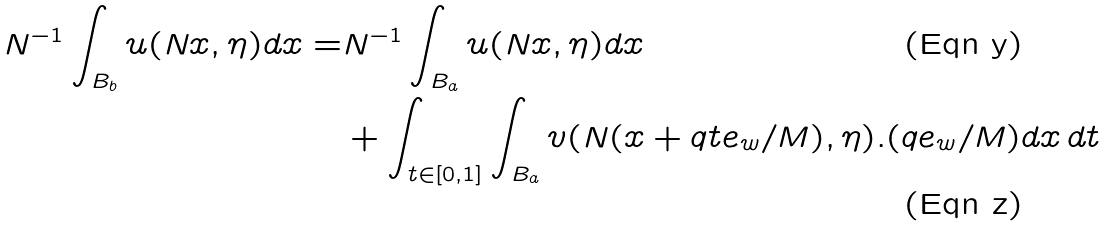<formula> <loc_0><loc_0><loc_500><loc_500>N ^ { - 1 } \int _ { B _ { b } } u ( N x , \eta ) d x = & N ^ { - 1 } \int _ { B _ { a } } u ( N x , \eta ) d x \\ & + \int _ { t \in [ 0 , 1 ] } \int _ { B _ { a } } v ( N ( x + q t e _ { w } / M ) , \eta ) . ( q e _ { w } / M ) d x \, d t</formula> 